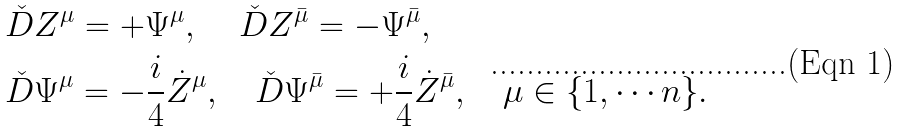<formula> <loc_0><loc_0><loc_500><loc_500>& \check { D } Z ^ { \mu } = + \Psi ^ { \mu } , \quad \, \check { D } Z ^ { \bar { \mu } } = - \Psi ^ { \bar { \mu } } , \\ & \check { D } \Psi ^ { \mu } = - \frac { i } { 4 } \dot { Z } ^ { \mu } , \quad \check { D } \Psi ^ { \bar { \mu } } = + \frac { i } { 4 } \dot { Z } ^ { \bar { \mu } } , \quad \mu \in \{ 1 , \cdots n \} .</formula> 